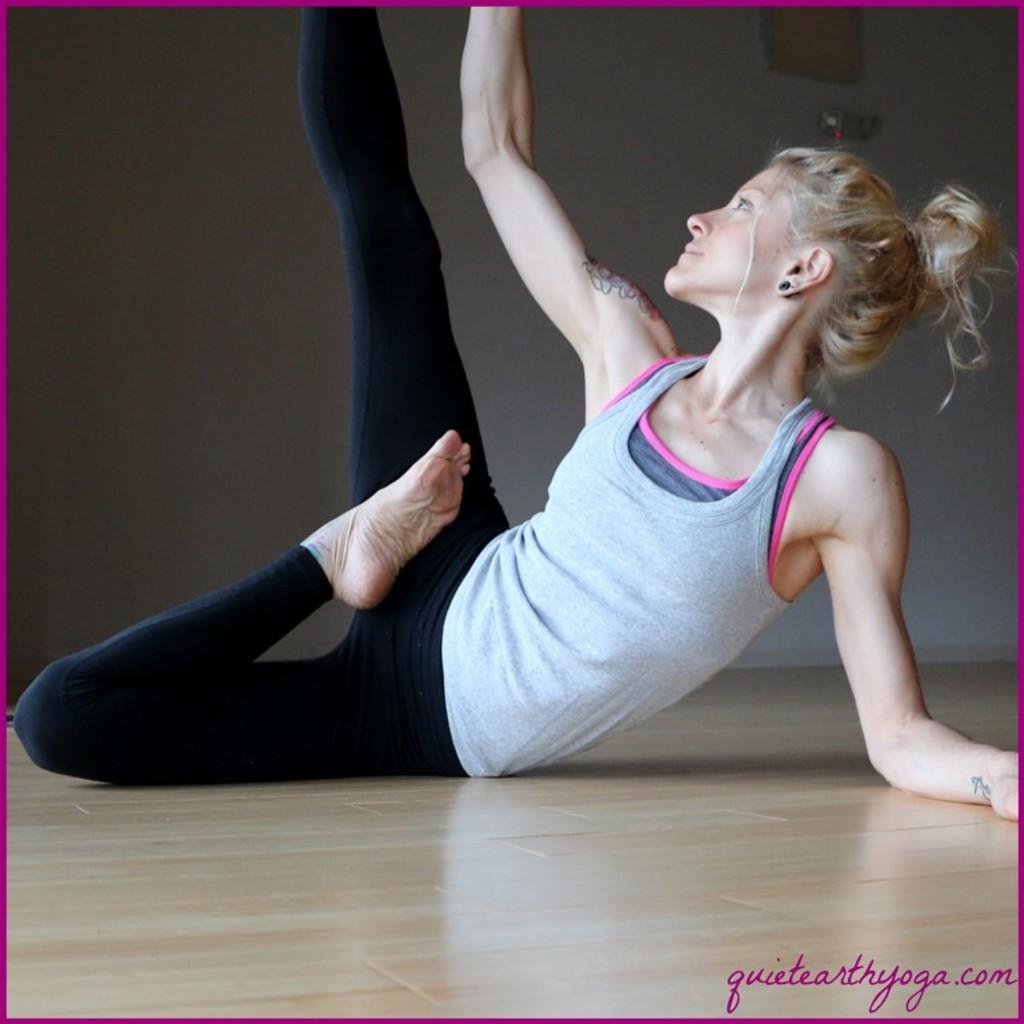Can you describe this image briefly? In this image, we can see a woman on the floor, it looks like she is doing exercise, in the background we can see the wall. 